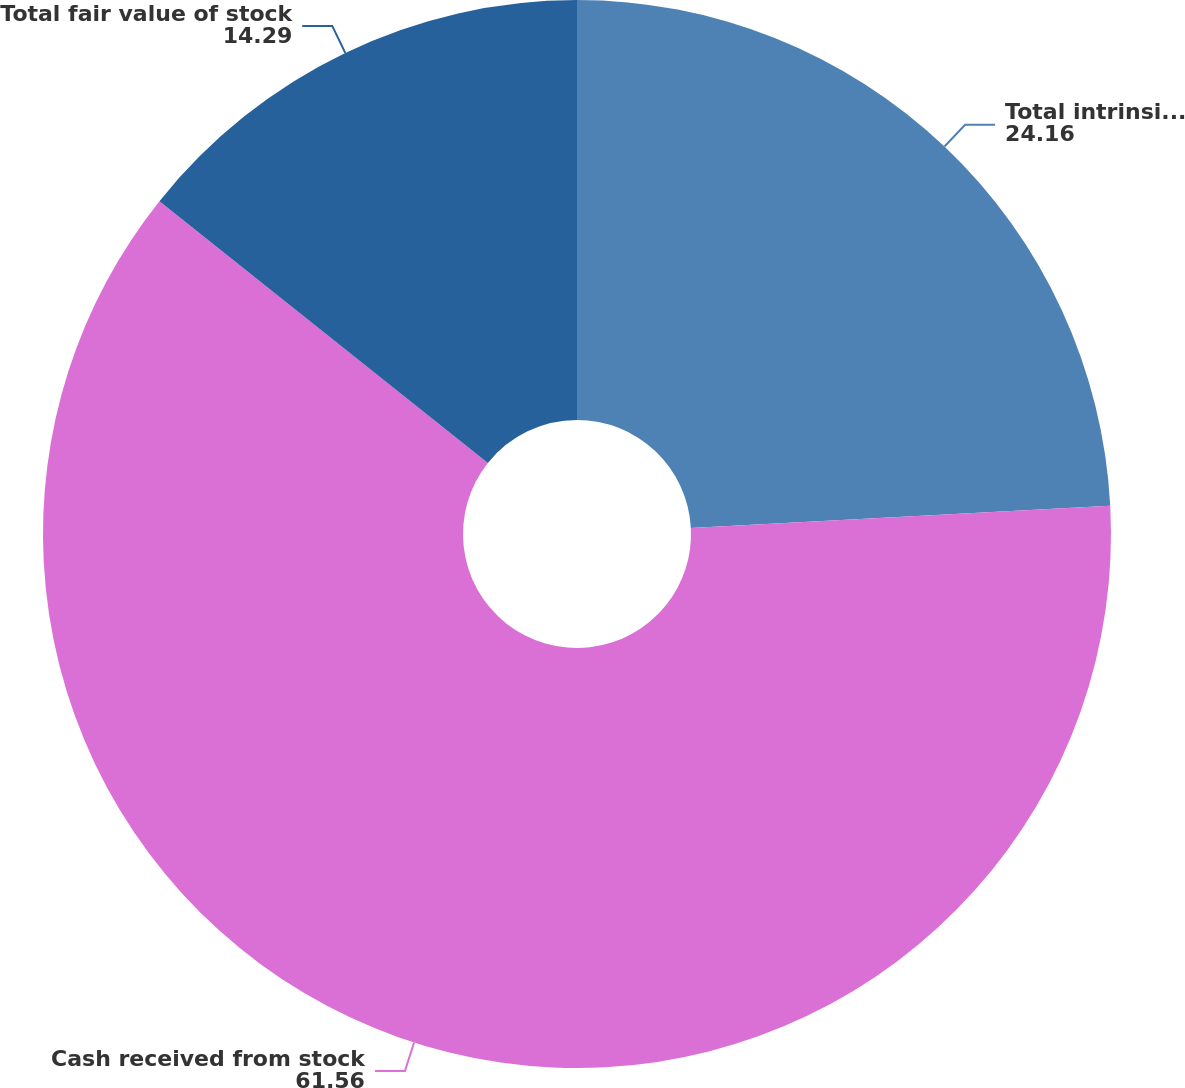<chart> <loc_0><loc_0><loc_500><loc_500><pie_chart><fcel>Total intrinsic value of stock<fcel>Cash received from stock<fcel>Total fair value of stock<nl><fcel>24.16%<fcel>61.56%<fcel>14.29%<nl></chart> 